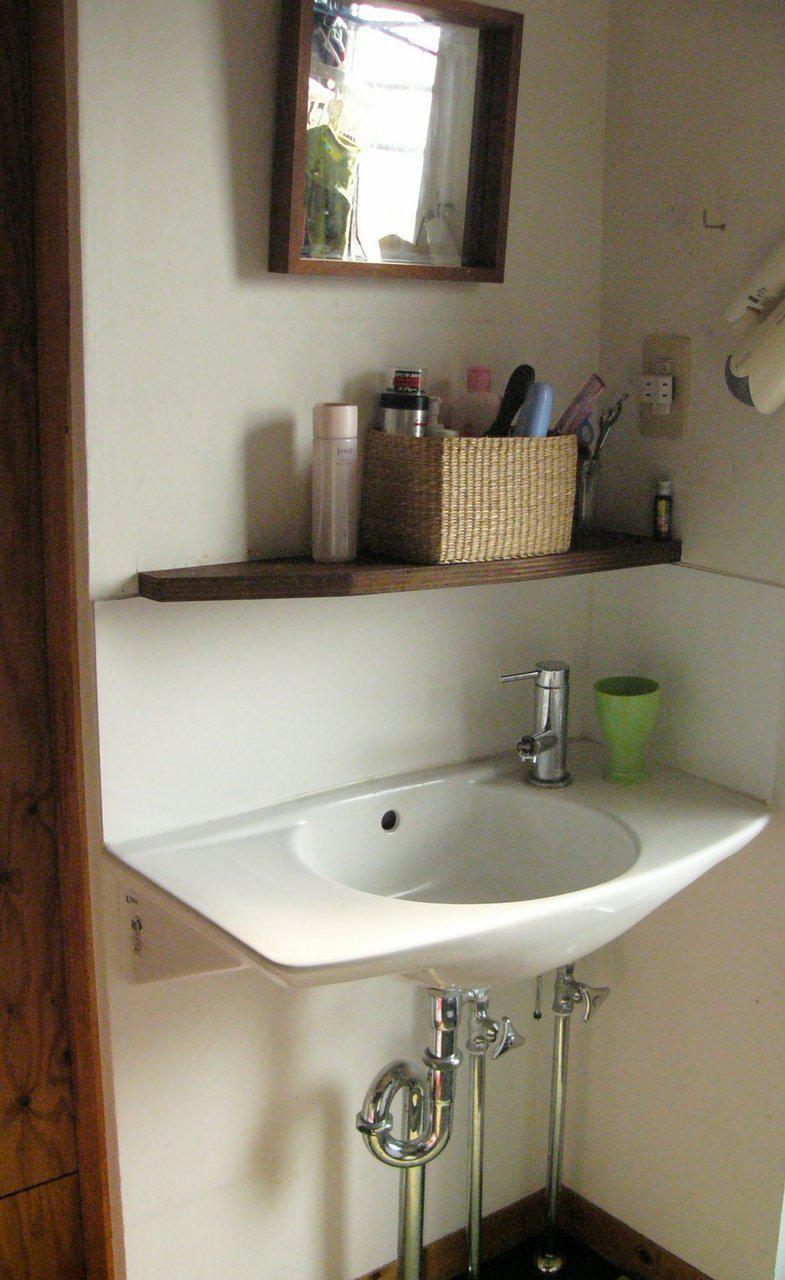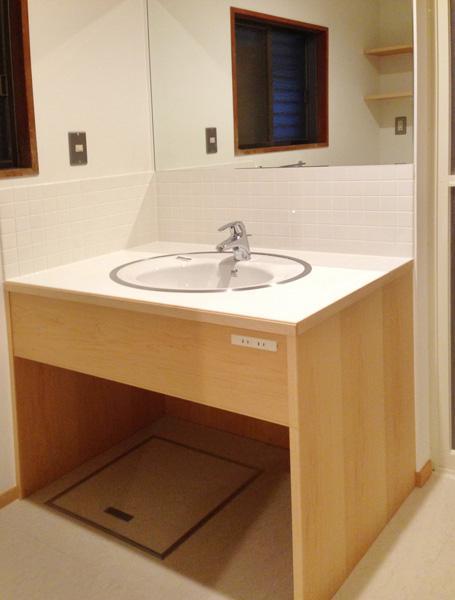The first image is the image on the left, the second image is the image on the right. Considering the images on both sides, is "One sink is a rectangular bowl." valid? Answer yes or no. No. 